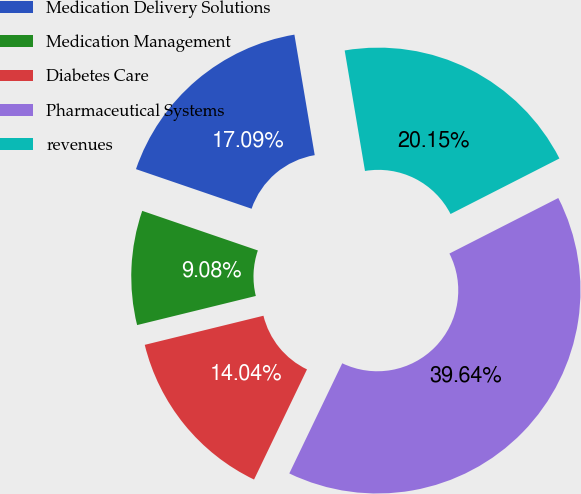Convert chart. <chart><loc_0><loc_0><loc_500><loc_500><pie_chart><fcel>Medication Delivery Solutions<fcel>Medication Management<fcel>Diabetes Care<fcel>Pharmaceutical Systems<fcel>revenues<nl><fcel>17.09%<fcel>9.08%<fcel>14.04%<fcel>39.64%<fcel>20.15%<nl></chart> 